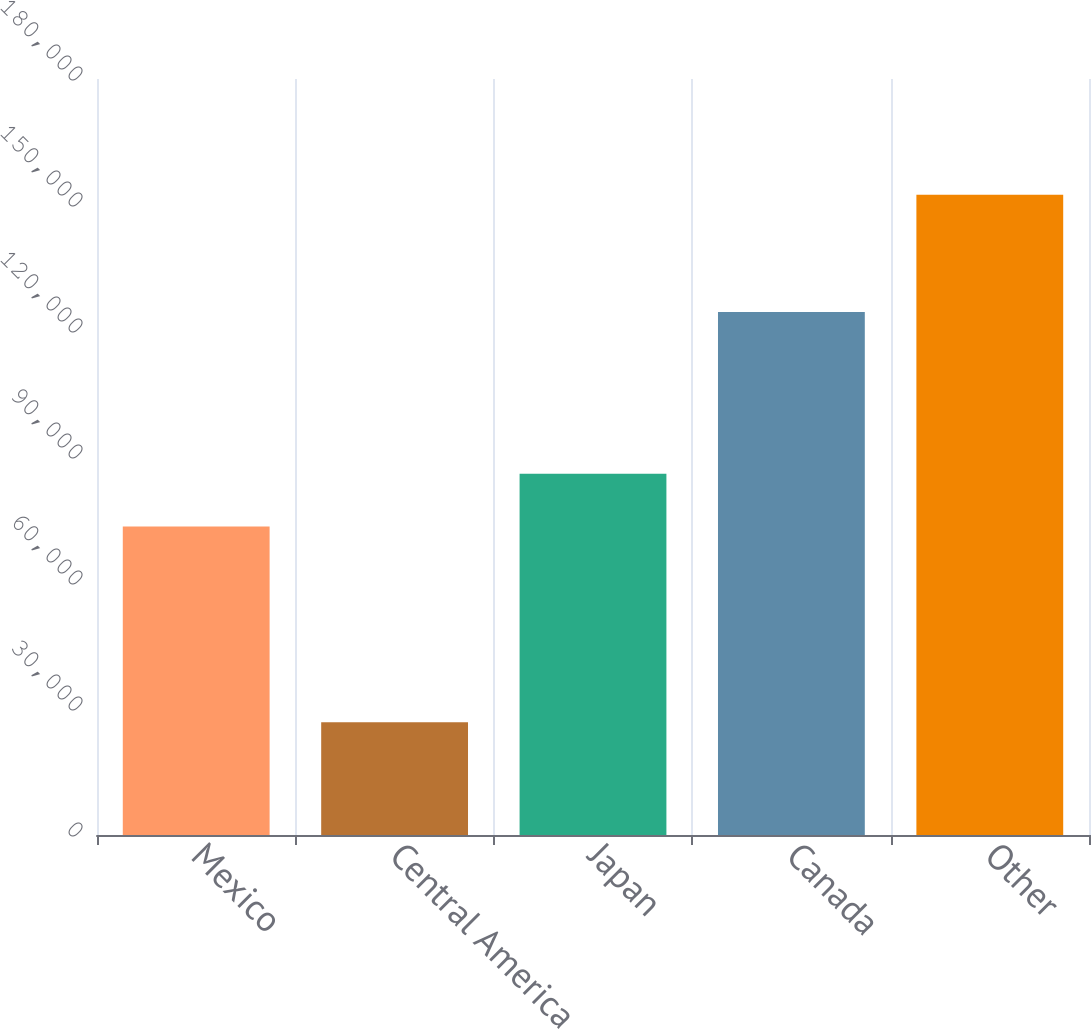<chart> <loc_0><loc_0><loc_500><loc_500><bar_chart><fcel>Mexico<fcel>Central America<fcel>Japan<fcel>Canada<fcel>Other<nl><fcel>73427<fcel>26851<fcel>85983.4<fcel>124500<fcel>152415<nl></chart> 